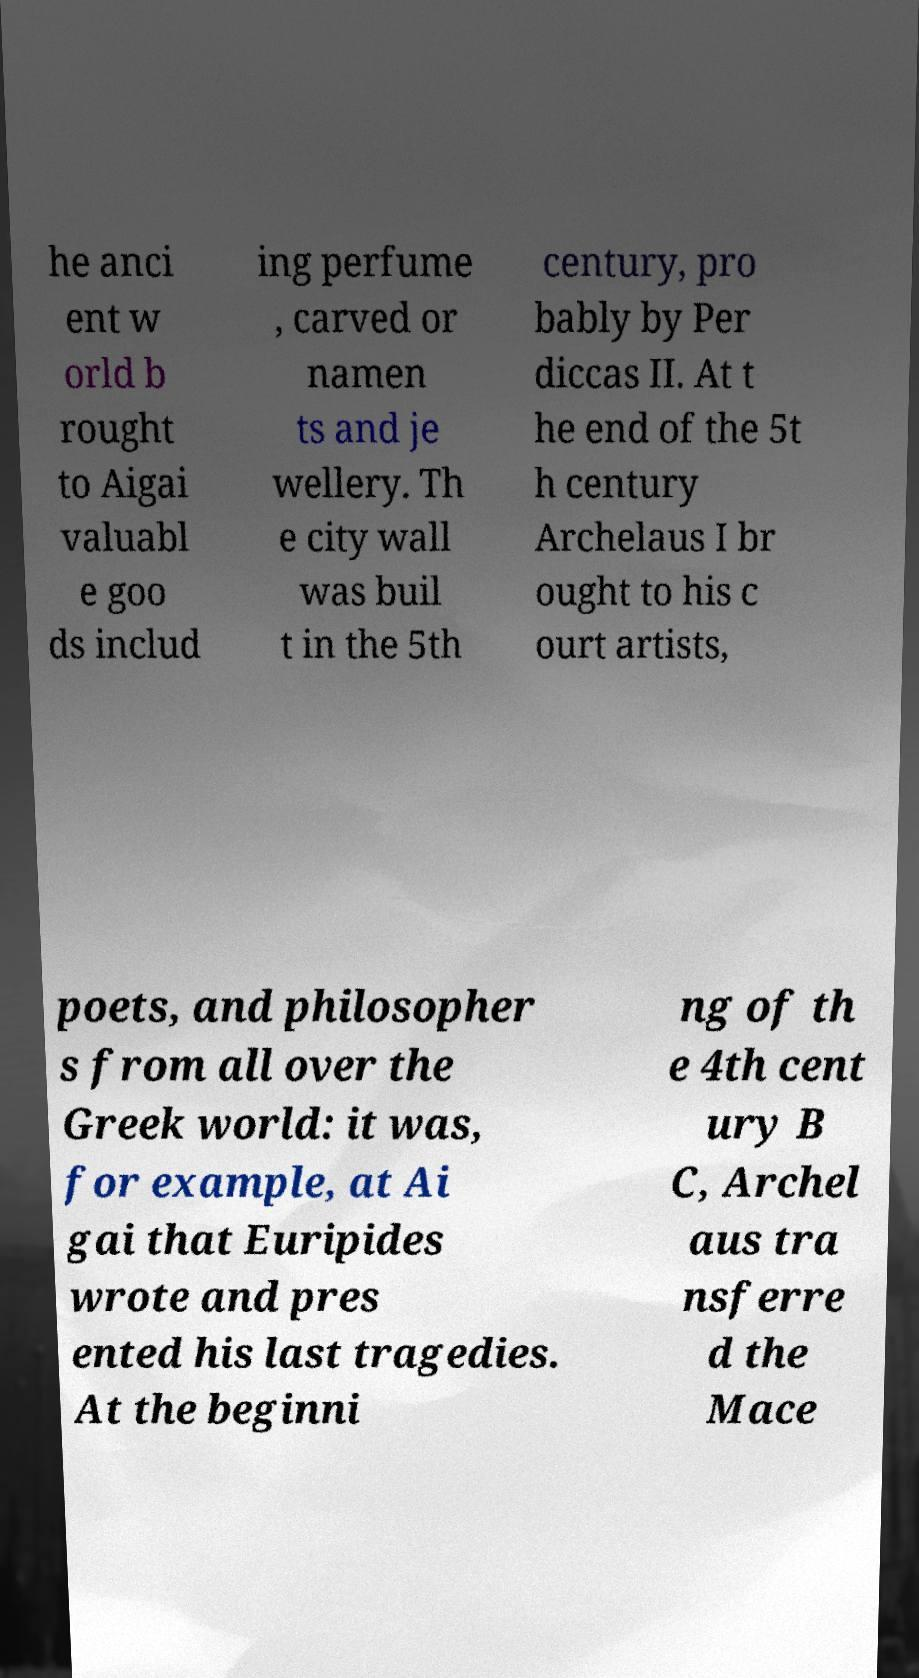What messages or text are displayed in this image? I need them in a readable, typed format. he anci ent w orld b rought to Aigai valuabl e goo ds includ ing perfume , carved or namen ts and je wellery. Th e city wall was buil t in the 5th century, pro bably by Per diccas II. At t he end of the 5t h century Archelaus I br ought to his c ourt artists, poets, and philosopher s from all over the Greek world: it was, for example, at Ai gai that Euripides wrote and pres ented his last tragedies. At the beginni ng of th e 4th cent ury B C, Archel aus tra nsferre d the Mace 